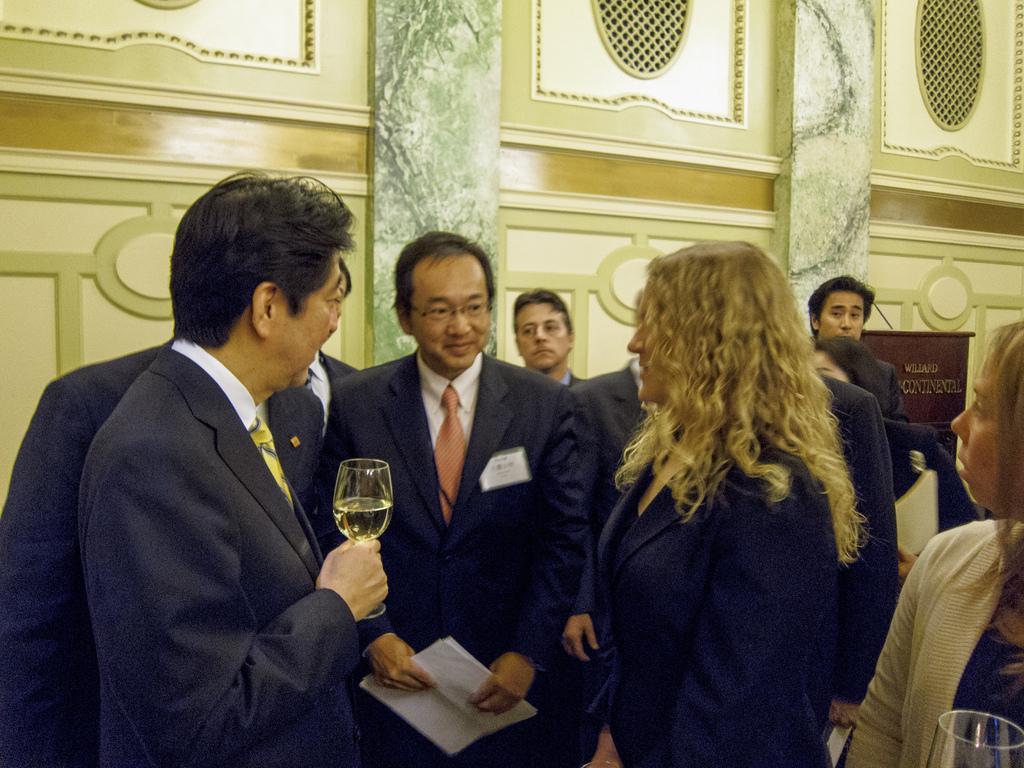Can you describe this image briefly? In this image I can see group of people are standing. Among them some are holding glasses and this man is holding papers. In the background I can see a wall. 